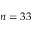Convert formula to latex. <formula><loc_0><loc_0><loc_500><loc_500>n = 3 3</formula> 